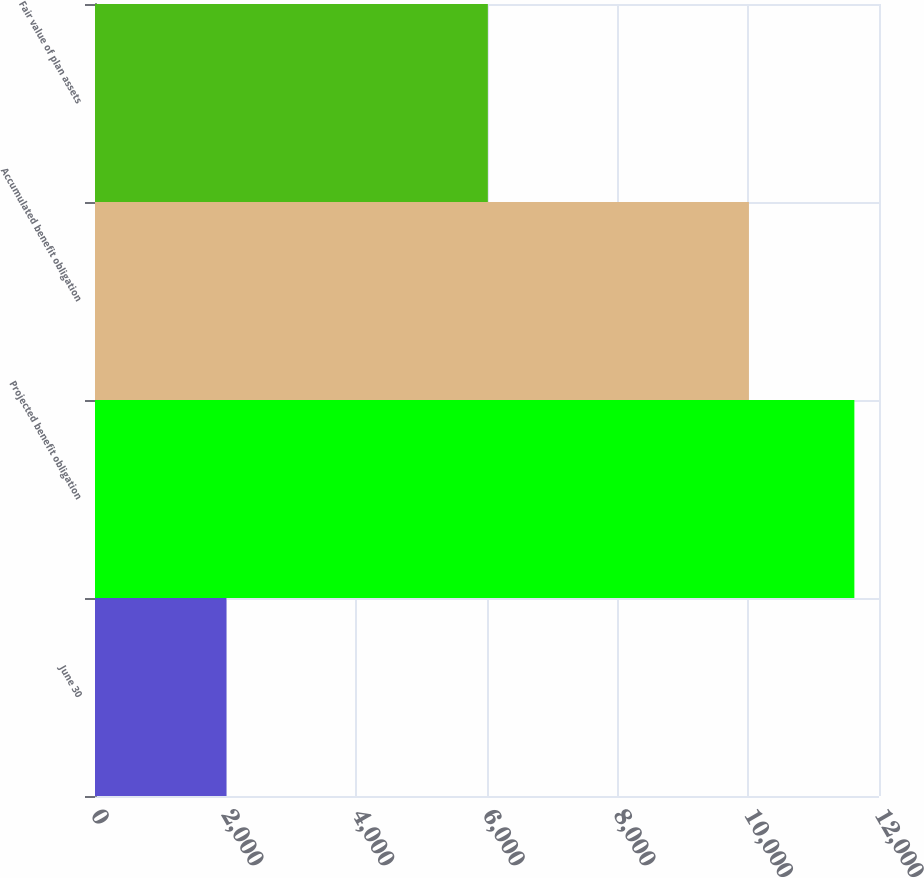<chart> <loc_0><loc_0><loc_500><loc_500><bar_chart><fcel>June 30<fcel>Projected benefit obligation<fcel>Accumulated benefit obligation<fcel>Fair value of plan assets<nl><fcel>2012<fcel>11623<fcel>10009<fcel>6013<nl></chart> 